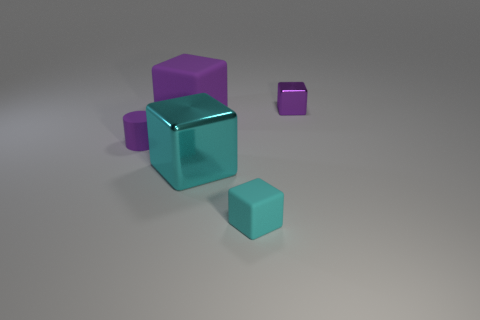Add 4 big blocks. How many objects exist? 9 Add 3 rubber objects. How many rubber objects exist? 6 Subtract all cyan cubes. How many cubes are left? 2 Subtract all large purple rubber blocks. How many blocks are left? 3 Subtract 0 green spheres. How many objects are left? 5 Subtract all cylinders. How many objects are left? 4 Subtract 1 cylinders. How many cylinders are left? 0 Subtract all yellow cylinders. Subtract all green spheres. How many cylinders are left? 1 Subtract all purple spheres. How many purple blocks are left? 2 Subtract all cyan rubber things. Subtract all large cyan shiny objects. How many objects are left? 3 